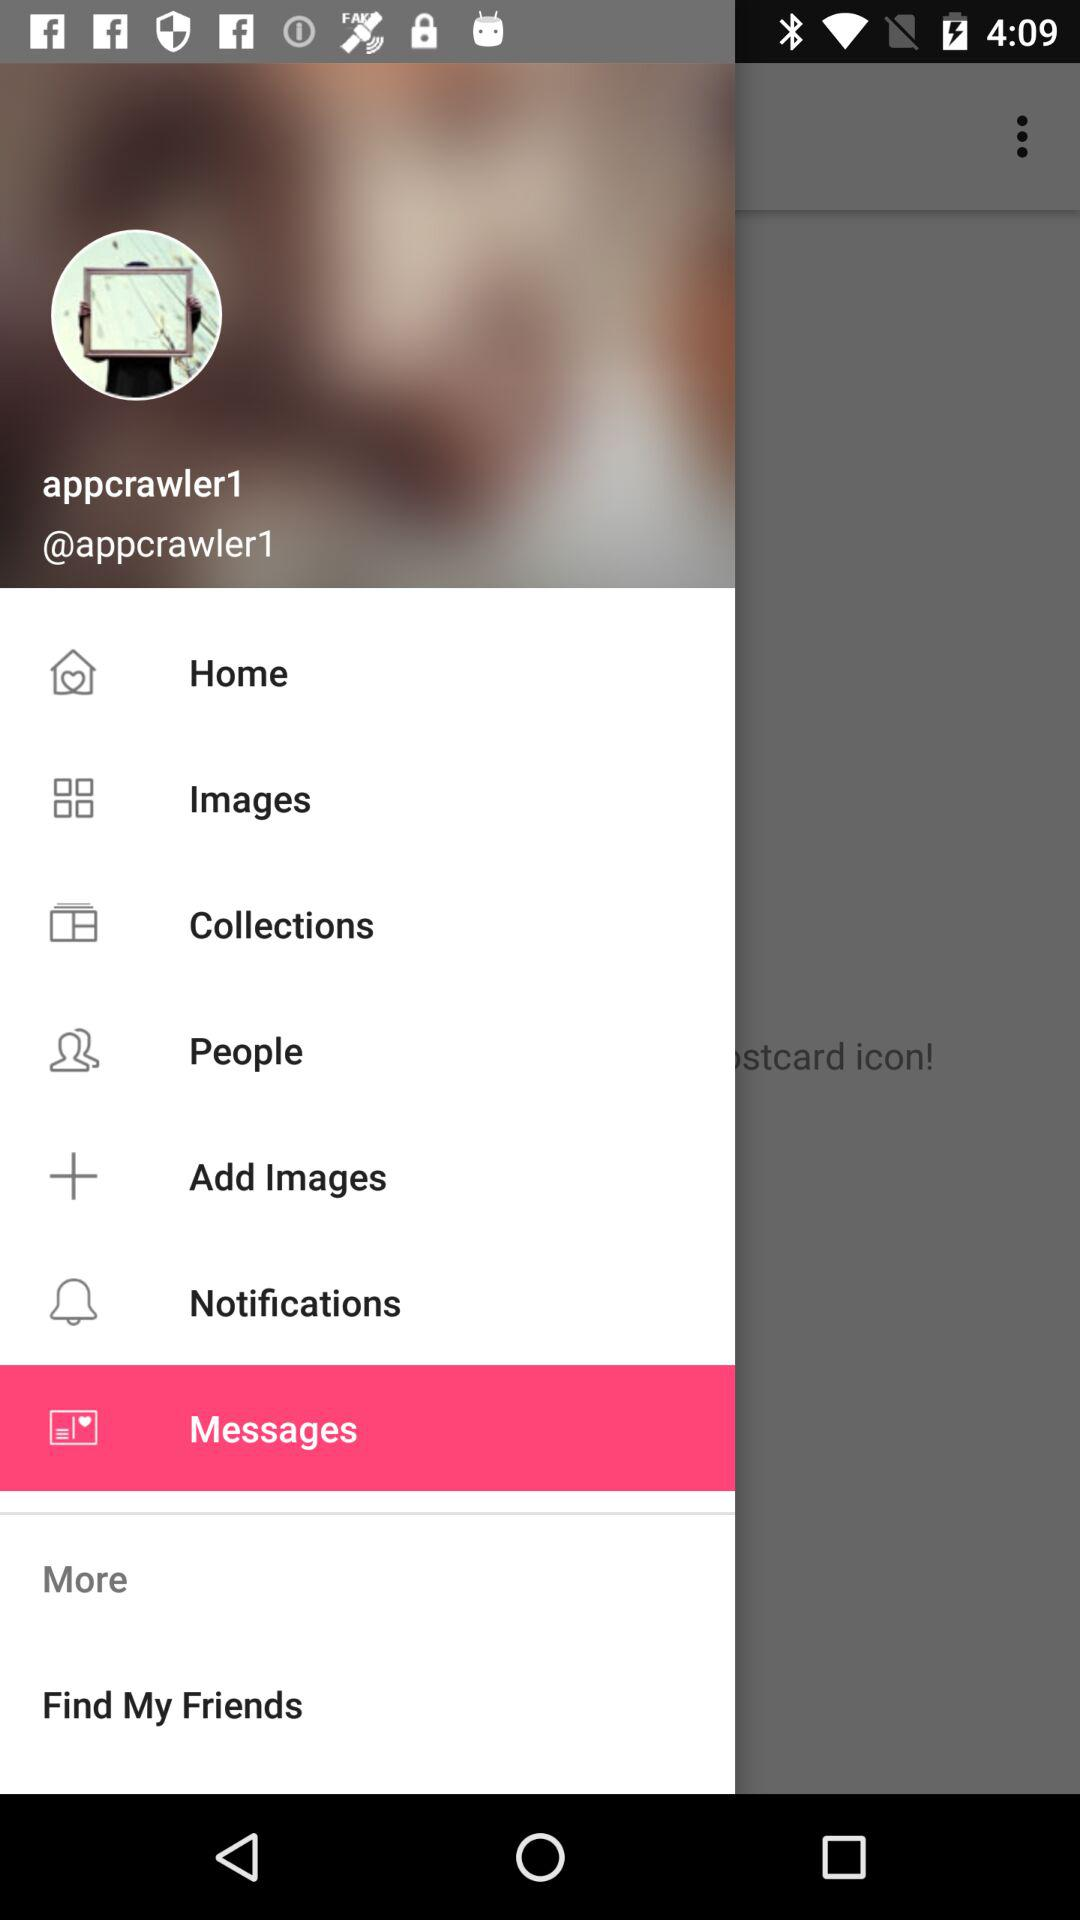What option is selected? The selected option is "Messages". 